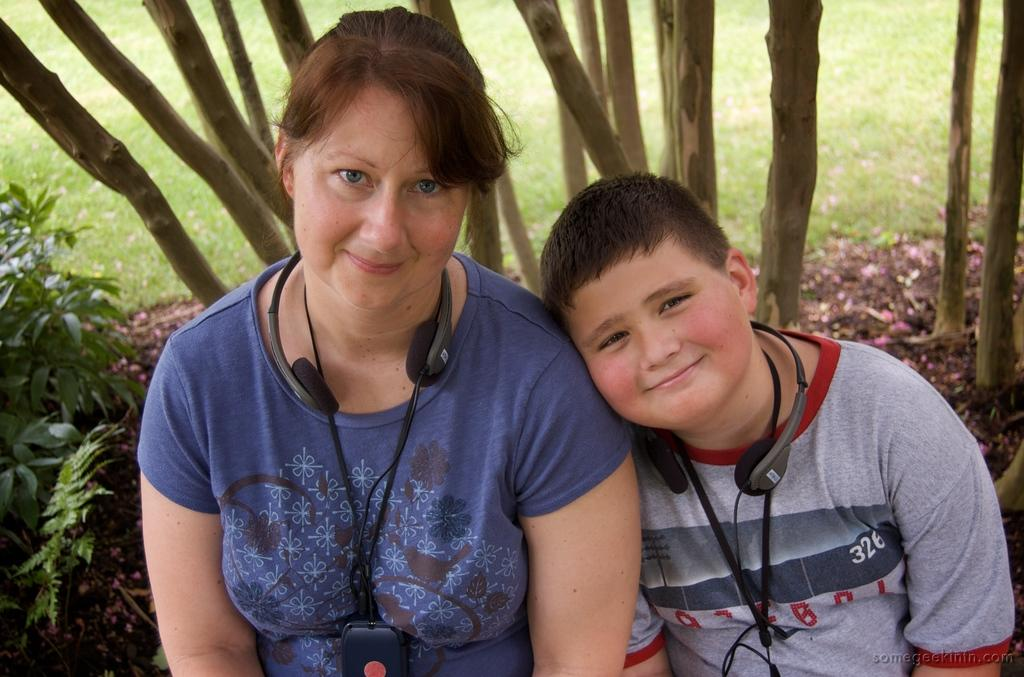Who is present in the image? There is a woman and a boy in the image. What are they both wearing? Both the woman and the boy are wearing headphones. What can be seen in the background of the image? There are trees in the background of the image. What is located on the left side of the image? There are plants on the left side of the image. What type of treatment is the boy receiving for his arithmetic skills in the image? There is no indication in the image that the boy is receiving any treatment for his arithmetic skills, nor is there any mention of arithmetic in the provided facts. What color is the cap the woman is wearing in the image? There is no cap visible in the image; the woman is wearing headphones. 